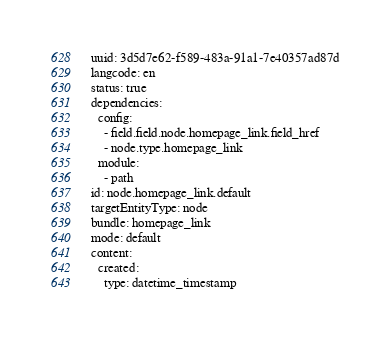Convert code to text. <code><loc_0><loc_0><loc_500><loc_500><_YAML_>uuid: 3d5d7e62-f589-483a-91a1-7e40357ad87d
langcode: en
status: true
dependencies:
  config:
    - field.field.node.homepage_link.field_href
    - node.type.homepage_link
  module:
    - path
id: node.homepage_link.default
targetEntityType: node
bundle: homepage_link
mode: default
content:
  created:
    type: datetime_timestamp</code> 